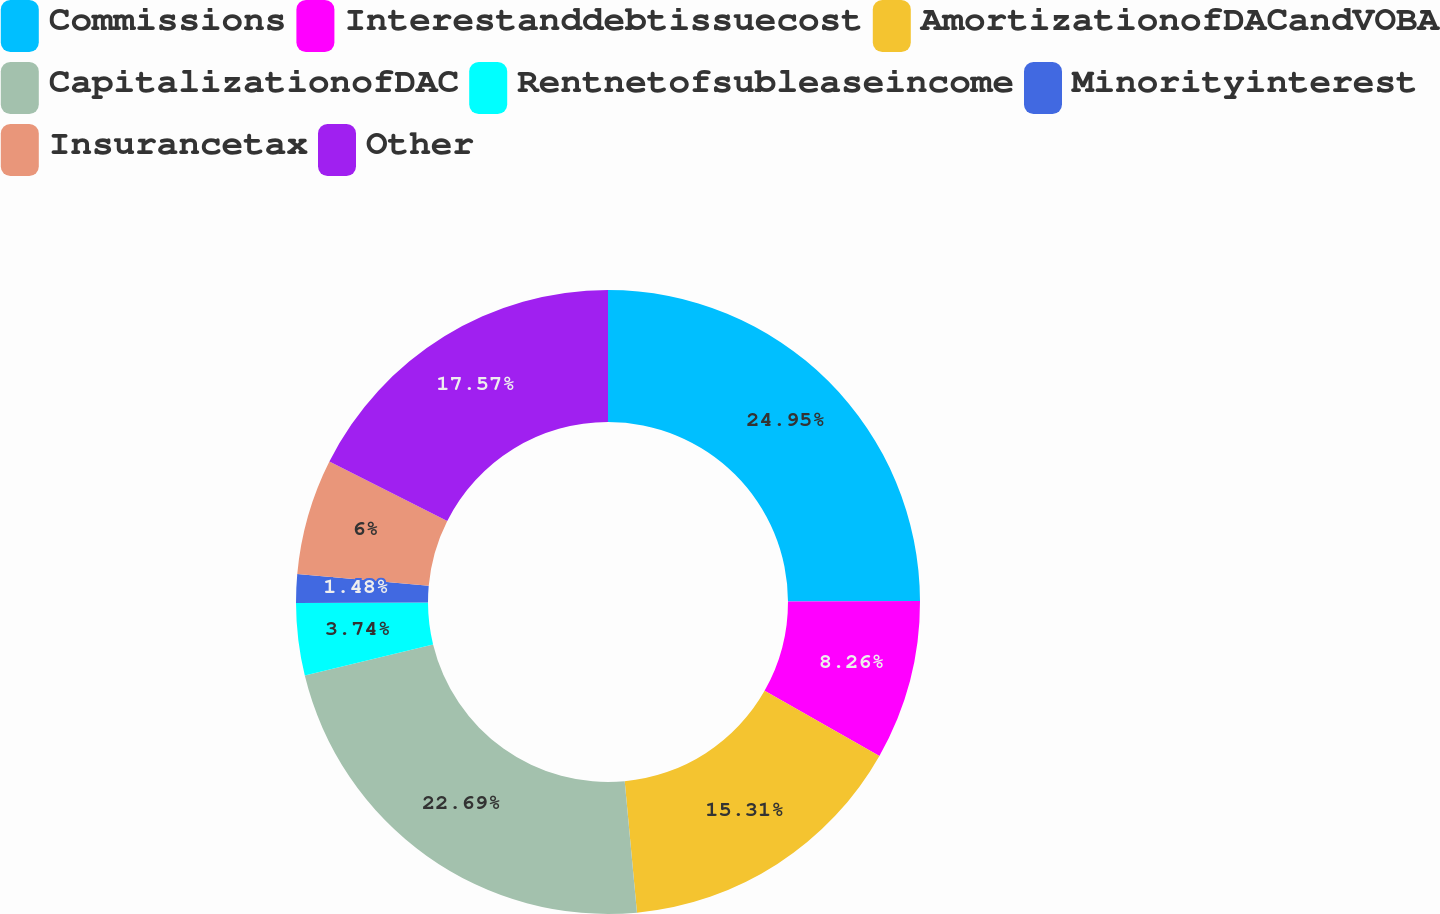Convert chart to OTSL. <chart><loc_0><loc_0><loc_500><loc_500><pie_chart><fcel>Commissions<fcel>Interestanddebtissuecost<fcel>AmortizationofDACandVOBA<fcel>CapitalizationofDAC<fcel>Rentnetofsubleaseincome<fcel>Minorityinterest<fcel>Insurancetax<fcel>Other<nl><fcel>24.95%<fcel>8.26%<fcel>15.31%<fcel>22.69%<fcel>3.74%<fcel>1.48%<fcel>6.0%<fcel>17.57%<nl></chart> 